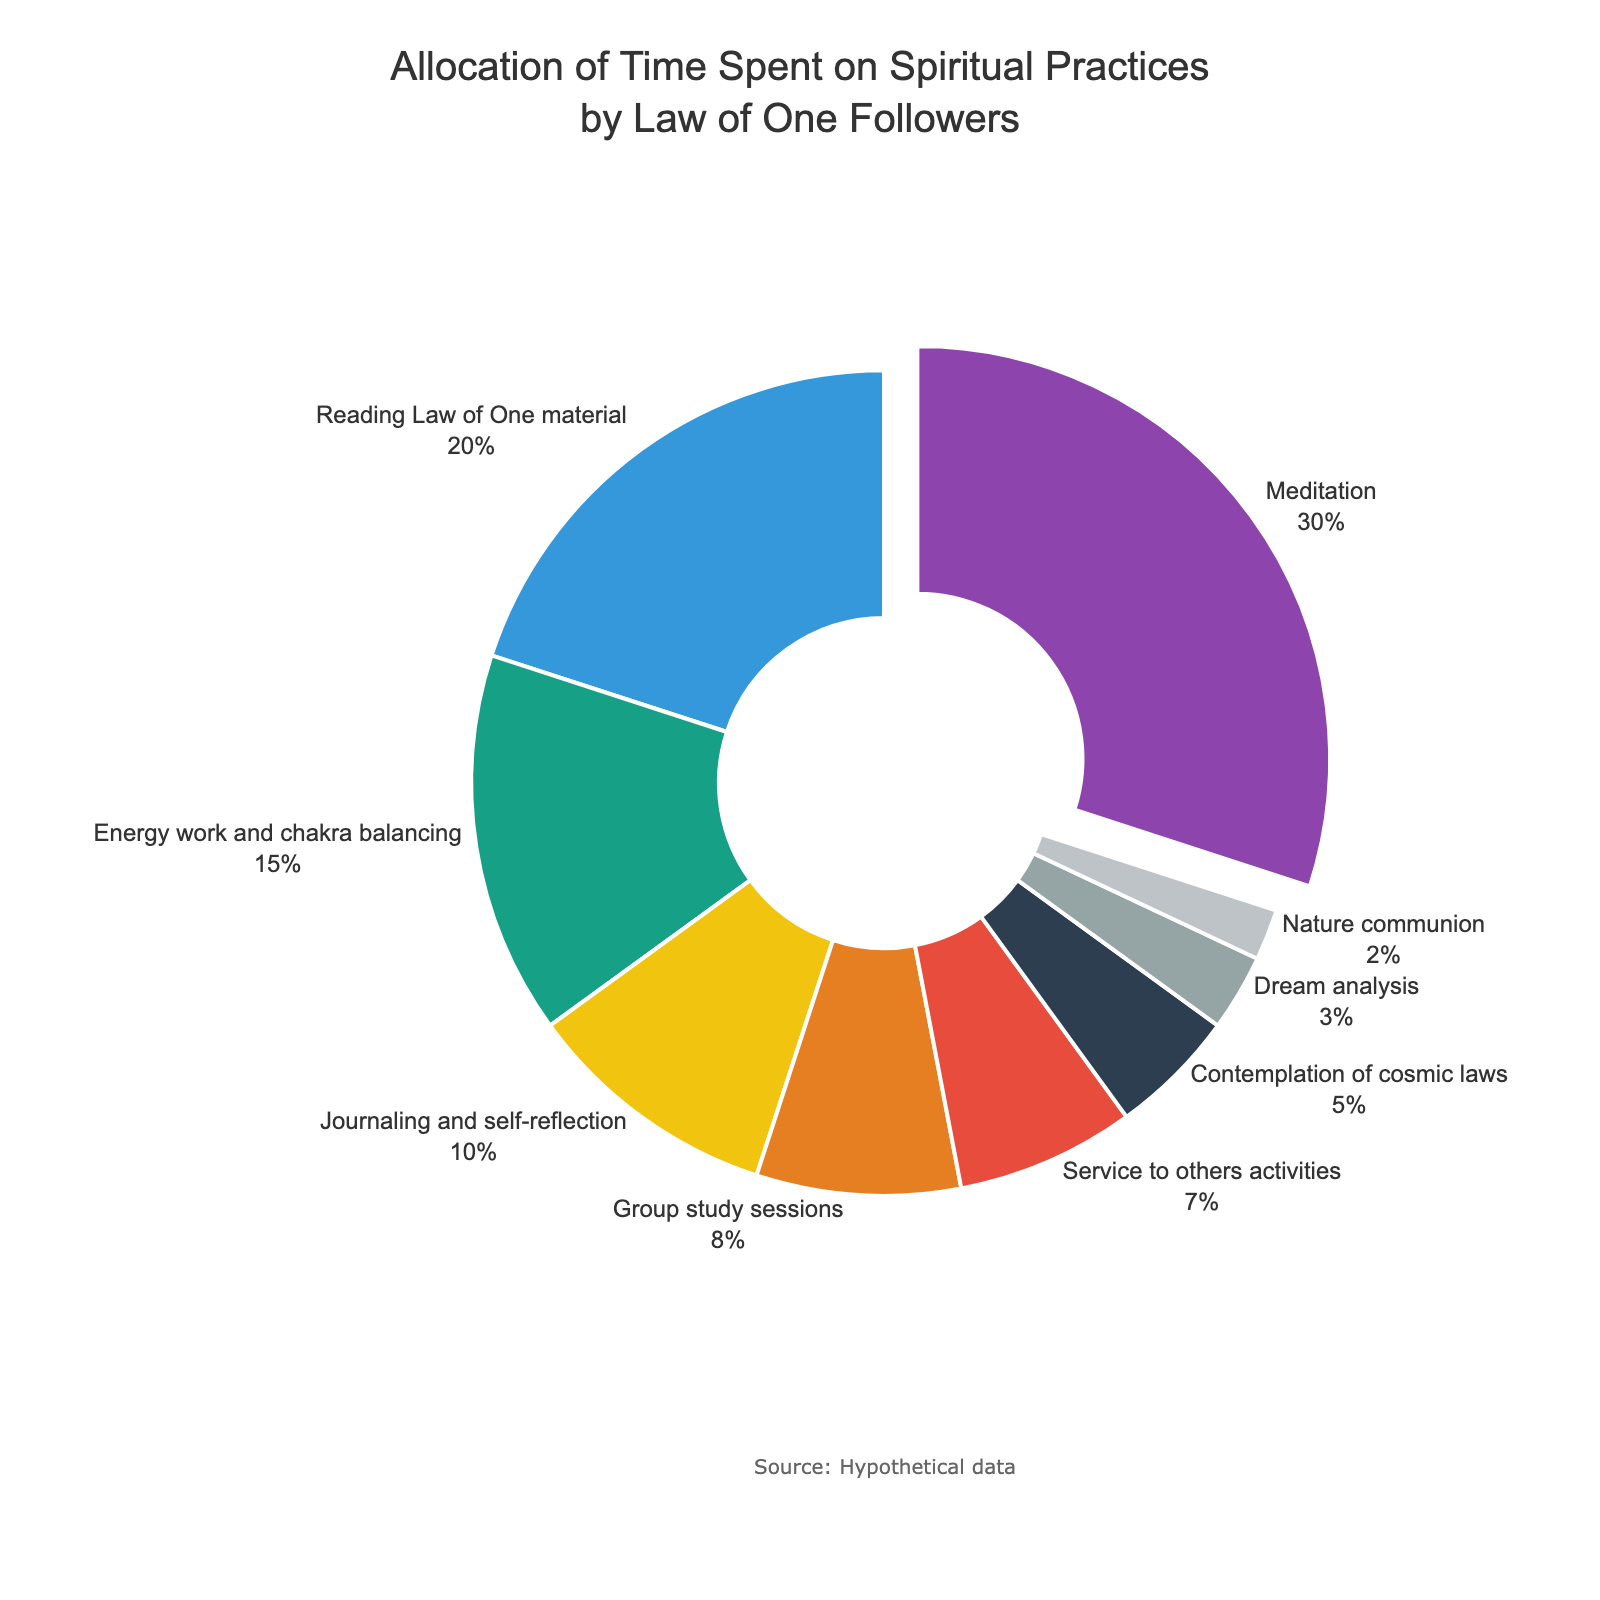Which practice has the largest allocation of time? The chart shows that the largest slice of the pie pulls out and labels it as "Meditation" with 30%.
Answer: Meditation What percentage of time is spent on Energy work and chakra balancing and Journaling and self-reflection combined? The figure shows Energy work and chakra balancing with 15% and Journaling and self-reflection with 10%. Adding them together gives 15% + 10% = 25%.
Answer: 25% Which practice has the smallest allocation of time? The smallest slice of the pie chart corresponds to "Nature communion", which is labeled with 2%.
Answer: Nature communion How much more time is allocated to Reading Law of One material compared to Dream analysis? Reading Law of One material is allocated 20%, while Dream analysis is allocated 3%. Subtracting these values gives 20% - 3% = 17%.
Answer: 17% What is the total percentage of time spent on Group study sessions and Service to others activities? Group study sessions have 8% and Service to others activities have 7%. Adding these gives 8% + 7% = 15%.
Answer: 15% Which practice has more time allocation: Contemplation of cosmic laws or Journaling and self-reflection? By comparing the pie chart slices, Journaling and self-reflection has 10% while Contemplation of cosmic laws has 5%. Therefore, Journaling and self-reflection has more time allocated.
Answer: Journaling and self-reflection What is the second most allocated practice according to the pie chart? The second-largest slice belongs to "Reading Law of One material" with 20%.
Answer: Reading Law of One material How much more time is spent on Meditation than on Nature communion? Meditation is allocated 30% and Nature communion is allocated 2%. Subtracting these values gives 30% - 2% = 28%.
Answer: 28% Which practice accounts for a higher percentage: Service to others activities or Dream analysis? By comparing the pie chart slices, Service to others activities accounts for 7% while Dream analysis accounts for 3%. Thus, Service to others activities accounts for a higher percentage.
Answer: Service to others activities 